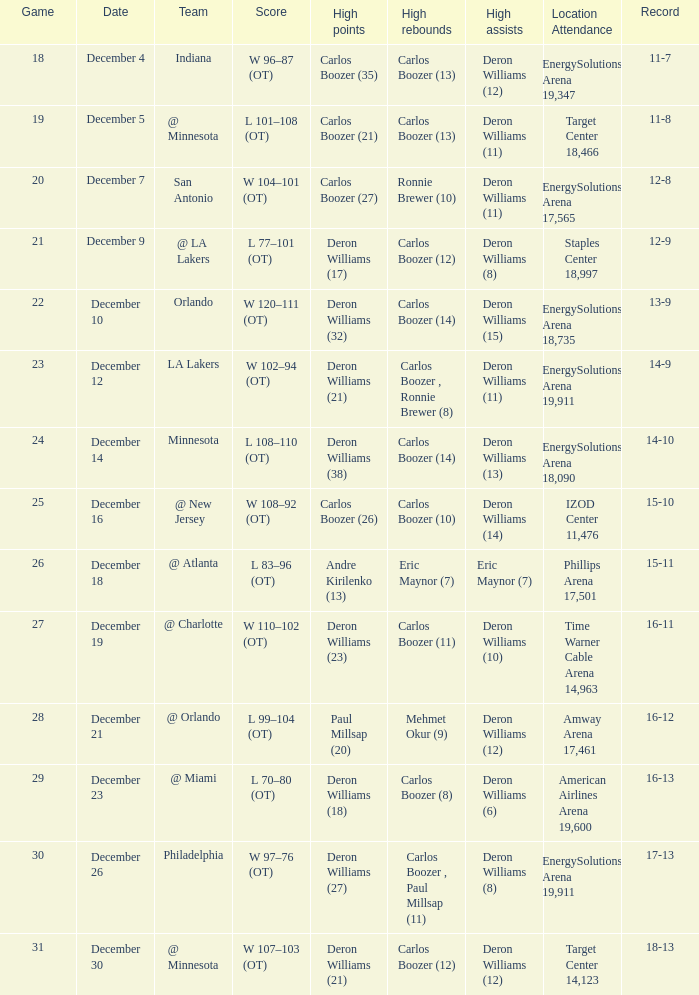When was the game in which Deron Williams (13) did the high assists played? December 14. 